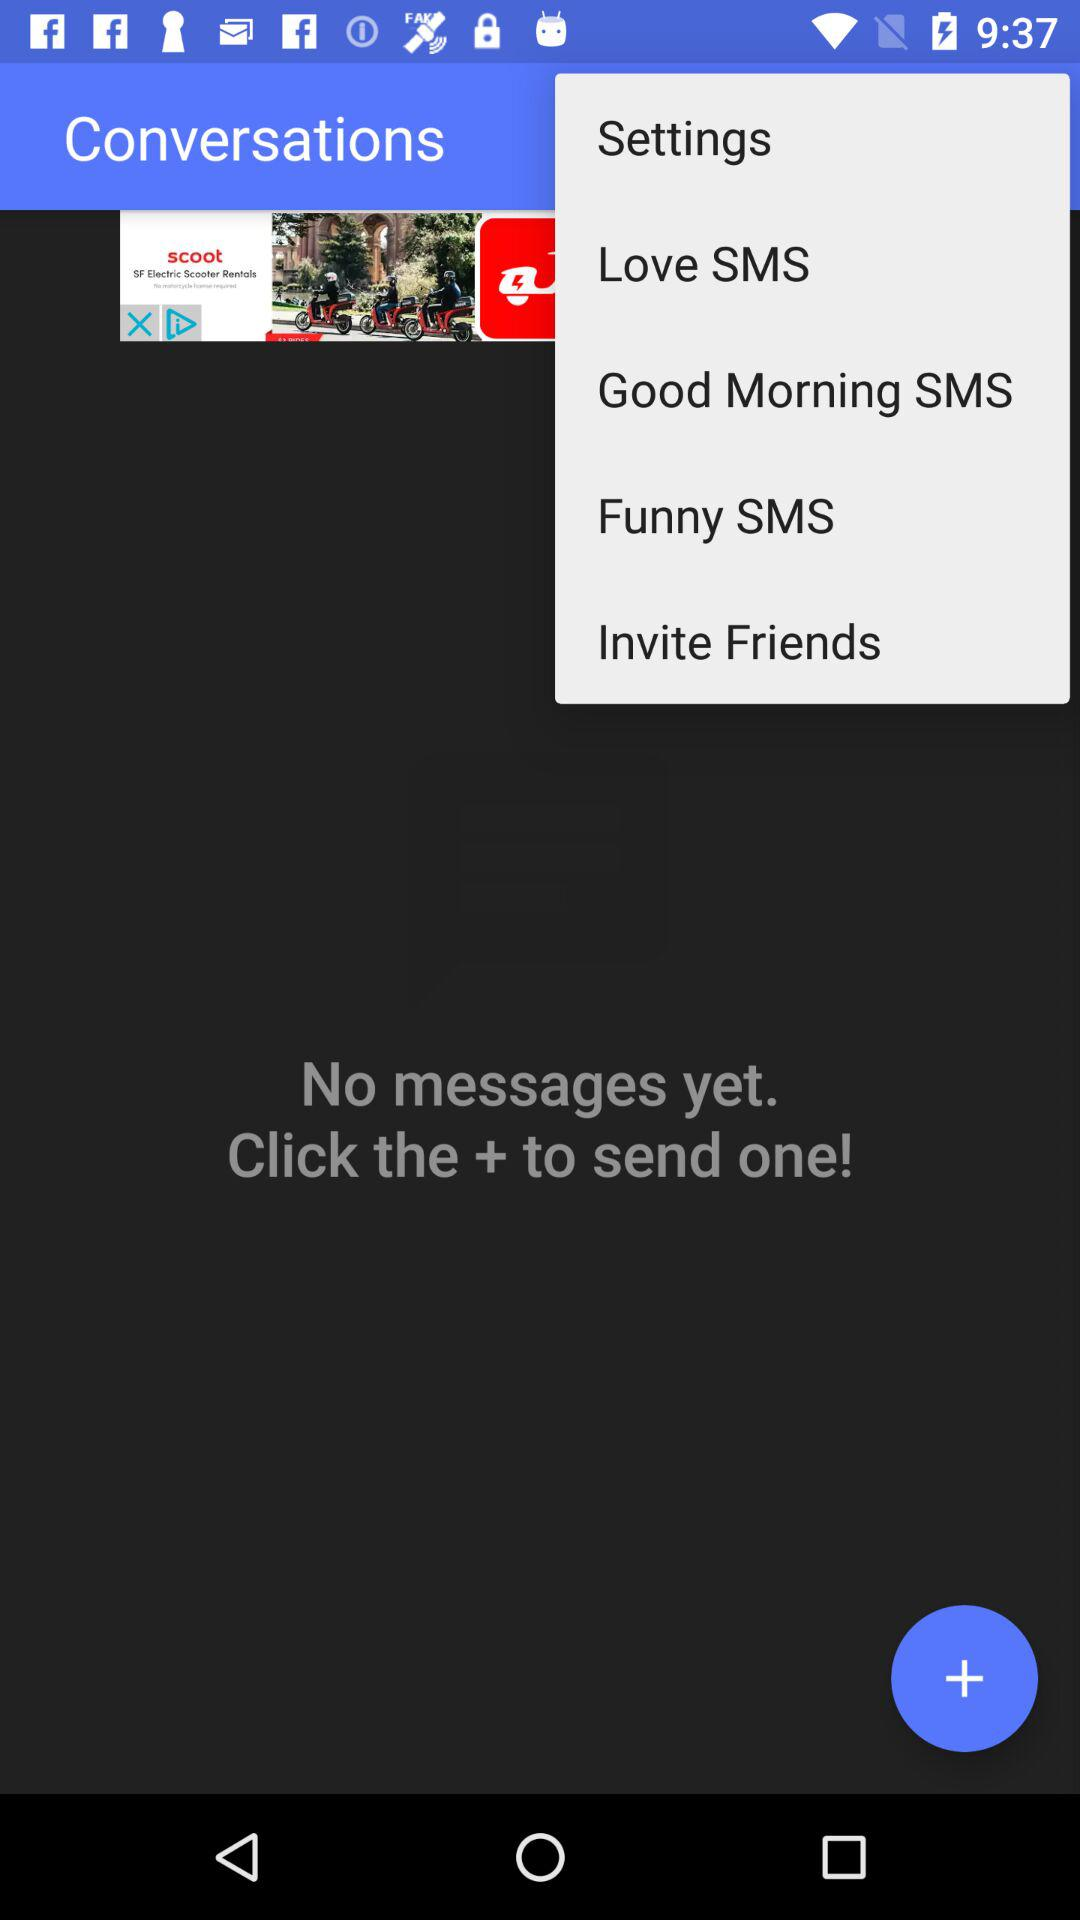What is the application name? The application name is "Conversations". 